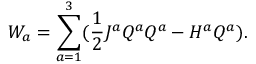Convert formula to latex. <formula><loc_0><loc_0><loc_500><loc_500>W _ { a } = \sum _ { a = 1 } ^ { 3 } ( \frac { 1 } { 2 } J ^ { a } Q ^ { a } Q ^ { a } - H ^ { a } Q ^ { a } ) .</formula> 